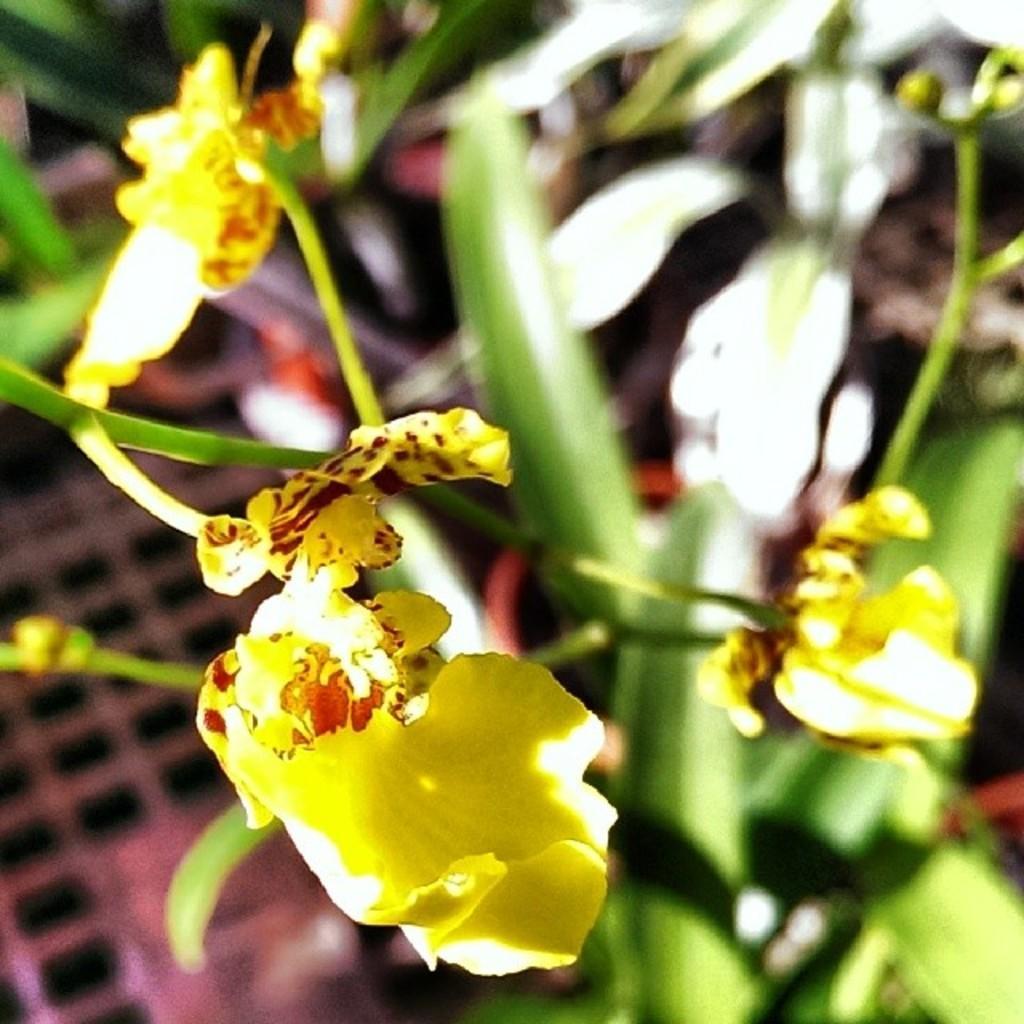Could you give a brief overview of what you see in this image? In the picture I can see flower plants. These flowers are yellow in color. The background of the image is blurred. 